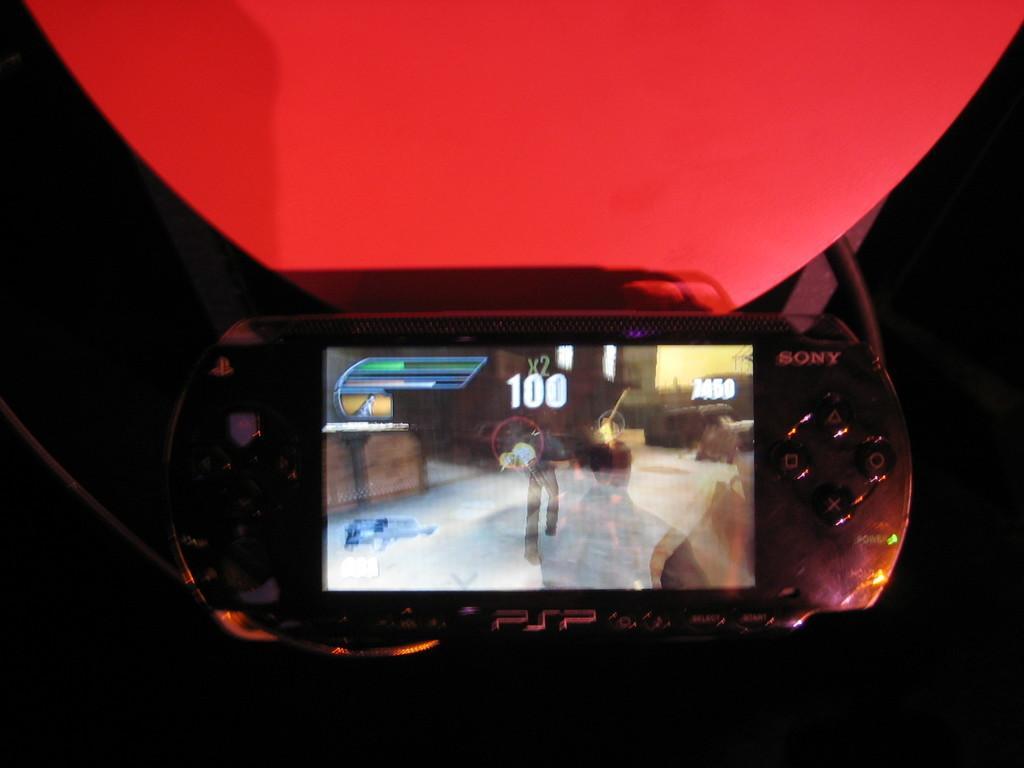Could you give a brief overview of what you see in this image? In this picture I can observe a video game in the middle of the picture. This video game is in black color. The background is completely dark. 